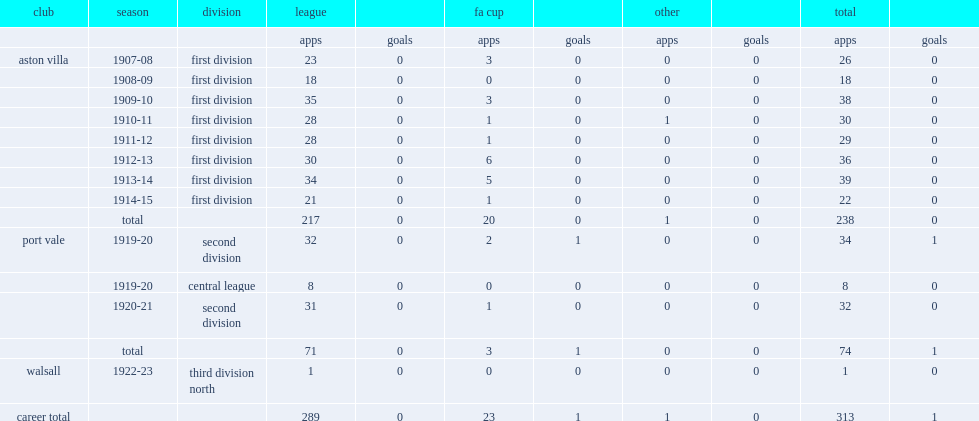How many games did villa play for lyons totally? 238.0. 